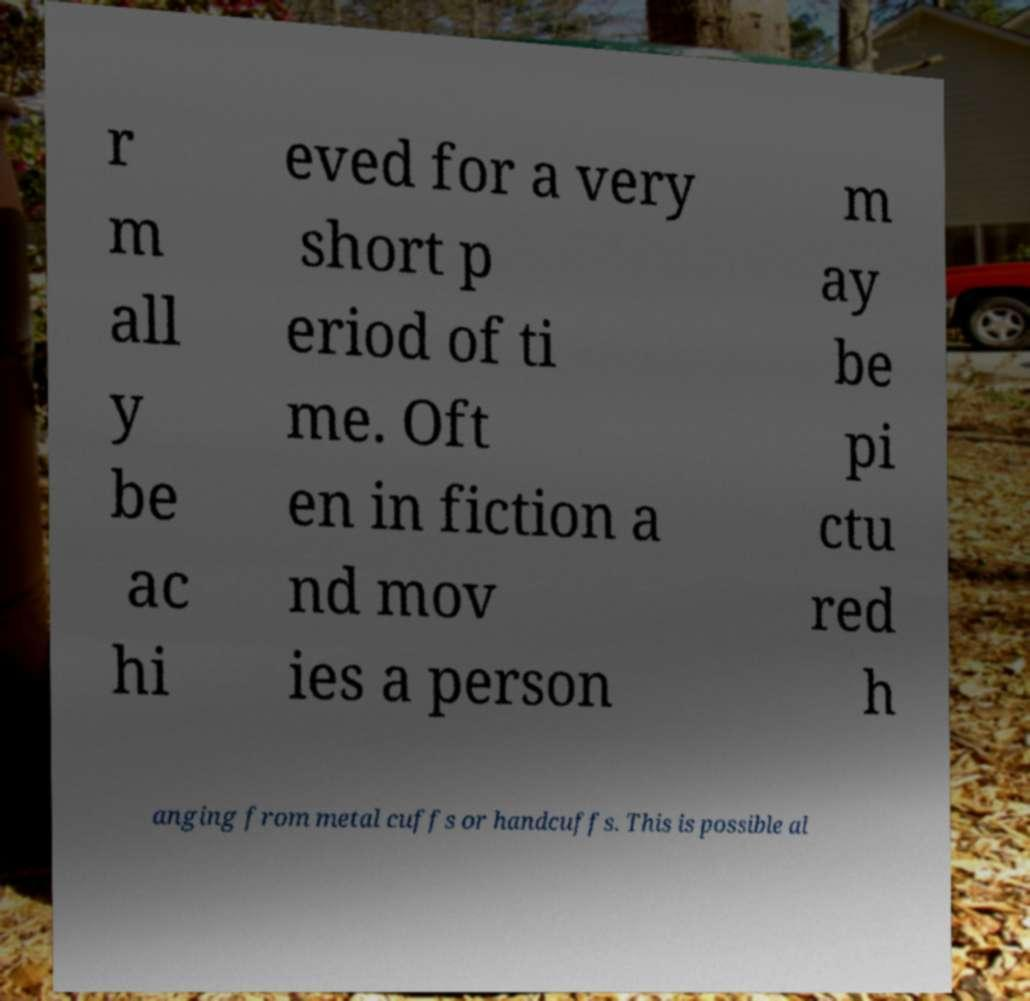What messages or text are displayed in this image? I need them in a readable, typed format. r m all y be ac hi eved for a very short p eriod of ti me. Oft en in fiction a nd mov ies a person m ay be pi ctu red h anging from metal cuffs or handcuffs. This is possible al 